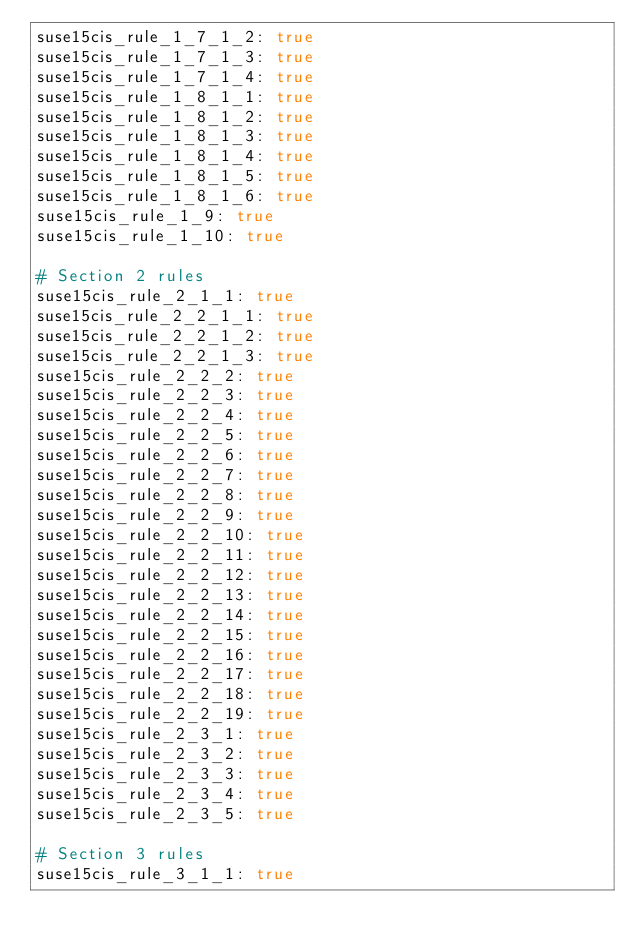<code> <loc_0><loc_0><loc_500><loc_500><_YAML_>suse15cis_rule_1_7_1_2: true
suse15cis_rule_1_7_1_3: true
suse15cis_rule_1_7_1_4: true
suse15cis_rule_1_8_1_1: true
suse15cis_rule_1_8_1_2: true
suse15cis_rule_1_8_1_3: true
suse15cis_rule_1_8_1_4: true
suse15cis_rule_1_8_1_5: true
suse15cis_rule_1_8_1_6: true
suse15cis_rule_1_9: true
suse15cis_rule_1_10: true

# Section 2 rules
suse15cis_rule_2_1_1: true
suse15cis_rule_2_2_1_1: true
suse15cis_rule_2_2_1_2: true
suse15cis_rule_2_2_1_3: true
suse15cis_rule_2_2_2: true
suse15cis_rule_2_2_3: true
suse15cis_rule_2_2_4: true
suse15cis_rule_2_2_5: true
suse15cis_rule_2_2_6: true
suse15cis_rule_2_2_7: true
suse15cis_rule_2_2_8: true
suse15cis_rule_2_2_9: true
suse15cis_rule_2_2_10: true
suse15cis_rule_2_2_11: true
suse15cis_rule_2_2_12: true
suse15cis_rule_2_2_13: true
suse15cis_rule_2_2_14: true
suse15cis_rule_2_2_15: true
suse15cis_rule_2_2_16: true
suse15cis_rule_2_2_17: true
suse15cis_rule_2_2_18: true
suse15cis_rule_2_2_19: true
suse15cis_rule_2_3_1: true
suse15cis_rule_2_3_2: true
suse15cis_rule_2_3_3: true
suse15cis_rule_2_3_4: true
suse15cis_rule_2_3_5: true

# Section 3 rules
suse15cis_rule_3_1_1: true</code> 